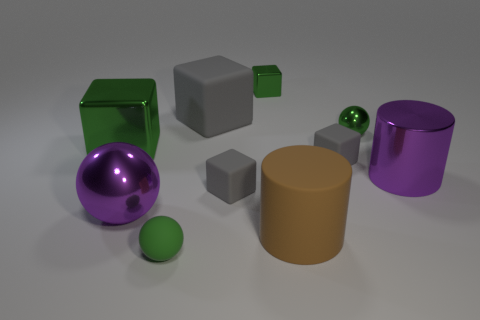Subtract all red spheres. How many gray blocks are left? 3 Subtract all large metal cubes. How many cubes are left? 4 Subtract 2 cubes. How many cubes are left? 3 Subtract all purple balls. Subtract all gray cylinders. How many balls are left? 2 Subtract all spheres. How many objects are left? 7 Subtract all big spheres. Subtract all big cyan rubber cylinders. How many objects are left? 9 Add 1 big green objects. How many big green objects are left? 2 Add 1 metallic cylinders. How many metallic cylinders exist? 2 Subtract 1 brown cylinders. How many objects are left? 9 